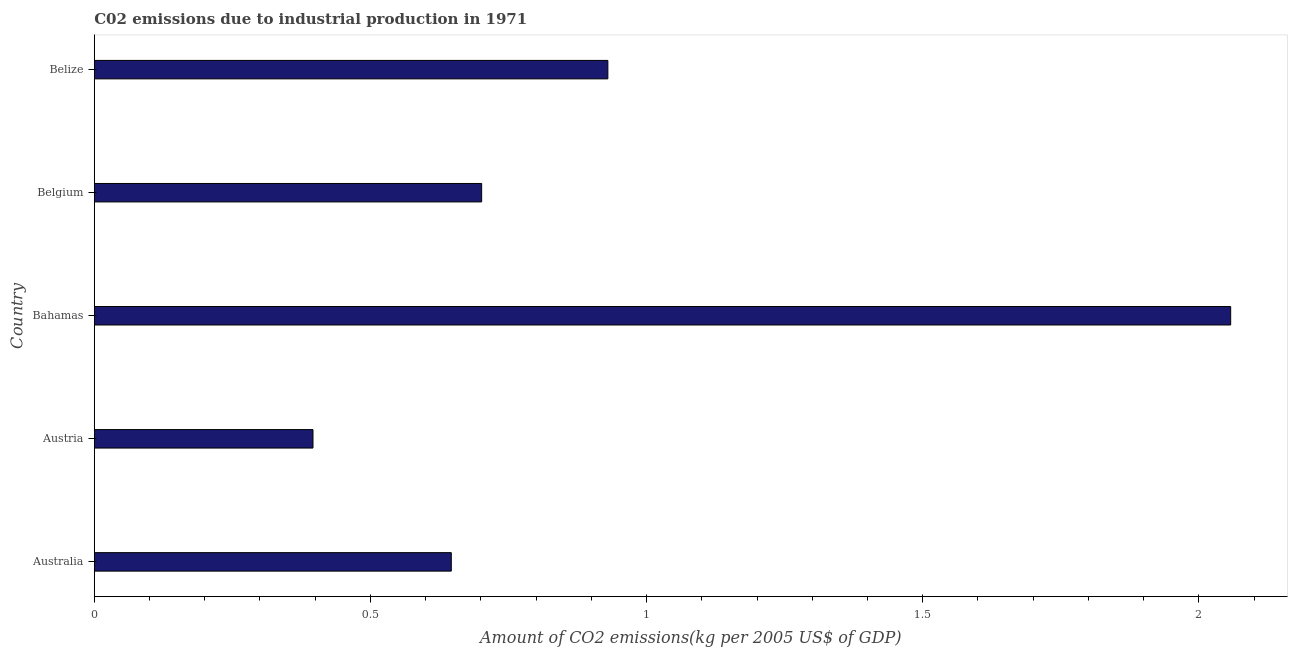Does the graph contain grids?
Make the answer very short. No. What is the title of the graph?
Give a very brief answer. C02 emissions due to industrial production in 1971. What is the label or title of the X-axis?
Ensure brevity in your answer.  Amount of CO2 emissions(kg per 2005 US$ of GDP). What is the amount of co2 emissions in Austria?
Your answer should be compact. 0.4. Across all countries, what is the maximum amount of co2 emissions?
Your answer should be compact. 2.06. Across all countries, what is the minimum amount of co2 emissions?
Keep it short and to the point. 0.4. In which country was the amount of co2 emissions maximum?
Ensure brevity in your answer.  Bahamas. What is the sum of the amount of co2 emissions?
Offer a terse response. 4.73. What is the difference between the amount of co2 emissions in Australia and Belize?
Make the answer very short. -0.28. What is the average amount of co2 emissions per country?
Provide a short and direct response. 0.95. What is the median amount of co2 emissions?
Ensure brevity in your answer.  0.7. What is the ratio of the amount of co2 emissions in Bahamas to that in Belize?
Provide a succinct answer. 2.21. Is the difference between the amount of co2 emissions in Australia and Belize greater than the difference between any two countries?
Offer a very short reply. No. What is the difference between the highest and the second highest amount of co2 emissions?
Your answer should be compact. 1.13. Is the sum of the amount of co2 emissions in Australia and Bahamas greater than the maximum amount of co2 emissions across all countries?
Give a very brief answer. Yes. What is the difference between the highest and the lowest amount of co2 emissions?
Your response must be concise. 1.66. In how many countries, is the amount of co2 emissions greater than the average amount of co2 emissions taken over all countries?
Your answer should be very brief. 1. How many bars are there?
Keep it short and to the point. 5. How many countries are there in the graph?
Make the answer very short. 5. Are the values on the major ticks of X-axis written in scientific E-notation?
Make the answer very short. No. What is the Amount of CO2 emissions(kg per 2005 US$ of GDP) of Australia?
Offer a terse response. 0.65. What is the Amount of CO2 emissions(kg per 2005 US$ of GDP) in Austria?
Offer a very short reply. 0.4. What is the Amount of CO2 emissions(kg per 2005 US$ of GDP) of Bahamas?
Keep it short and to the point. 2.06. What is the Amount of CO2 emissions(kg per 2005 US$ of GDP) of Belgium?
Your response must be concise. 0.7. What is the Amount of CO2 emissions(kg per 2005 US$ of GDP) in Belize?
Provide a short and direct response. 0.93. What is the difference between the Amount of CO2 emissions(kg per 2005 US$ of GDP) in Australia and Austria?
Make the answer very short. 0.25. What is the difference between the Amount of CO2 emissions(kg per 2005 US$ of GDP) in Australia and Bahamas?
Make the answer very short. -1.41. What is the difference between the Amount of CO2 emissions(kg per 2005 US$ of GDP) in Australia and Belgium?
Make the answer very short. -0.05. What is the difference between the Amount of CO2 emissions(kg per 2005 US$ of GDP) in Australia and Belize?
Your answer should be very brief. -0.28. What is the difference between the Amount of CO2 emissions(kg per 2005 US$ of GDP) in Austria and Bahamas?
Keep it short and to the point. -1.66. What is the difference between the Amount of CO2 emissions(kg per 2005 US$ of GDP) in Austria and Belgium?
Your answer should be compact. -0.31. What is the difference between the Amount of CO2 emissions(kg per 2005 US$ of GDP) in Austria and Belize?
Give a very brief answer. -0.53. What is the difference between the Amount of CO2 emissions(kg per 2005 US$ of GDP) in Bahamas and Belgium?
Your response must be concise. 1.36. What is the difference between the Amount of CO2 emissions(kg per 2005 US$ of GDP) in Bahamas and Belize?
Your response must be concise. 1.13. What is the difference between the Amount of CO2 emissions(kg per 2005 US$ of GDP) in Belgium and Belize?
Your answer should be very brief. -0.23. What is the ratio of the Amount of CO2 emissions(kg per 2005 US$ of GDP) in Australia to that in Austria?
Offer a very short reply. 1.63. What is the ratio of the Amount of CO2 emissions(kg per 2005 US$ of GDP) in Australia to that in Bahamas?
Give a very brief answer. 0.31. What is the ratio of the Amount of CO2 emissions(kg per 2005 US$ of GDP) in Australia to that in Belgium?
Ensure brevity in your answer.  0.92. What is the ratio of the Amount of CO2 emissions(kg per 2005 US$ of GDP) in Australia to that in Belize?
Provide a short and direct response. 0.69. What is the ratio of the Amount of CO2 emissions(kg per 2005 US$ of GDP) in Austria to that in Bahamas?
Ensure brevity in your answer.  0.19. What is the ratio of the Amount of CO2 emissions(kg per 2005 US$ of GDP) in Austria to that in Belgium?
Offer a very short reply. 0.56. What is the ratio of the Amount of CO2 emissions(kg per 2005 US$ of GDP) in Austria to that in Belize?
Offer a terse response. 0.43. What is the ratio of the Amount of CO2 emissions(kg per 2005 US$ of GDP) in Bahamas to that in Belgium?
Ensure brevity in your answer.  2.93. What is the ratio of the Amount of CO2 emissions(kg per 2005 US$ of GDP) in Bahamas to that in Belize?
Your answer should be very brief. 2.21. What is the ratio of the Amount of CO2 emissions(kg per 2005 US$ of GDP) in Belgium to that in Belize?
Give a very brief answer. 0.75. 